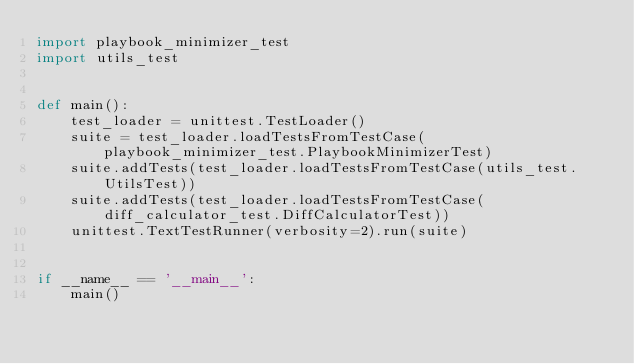<code> <loc_0><loc_0><loc_500><loc_500><_Python_>import playbook_minimizer_test
import utils_test


def main():
    test_loader = unittest.TestLoader()
    suite = test_loader.loadTestsFromTestCase(playbook_minimizer_test.PlaybookMinimizerTest)
    suite.addTests(test_loader.loadTestsFromTestCase(utils_test.UtilsTest))
    suite.addTests(test_loader.loadTestsFromTestCase(diff_calculator_test.DiffCalculatorTest))
    unittest.TextTestRunner(verbosity=2).run(suite)


if __name__ == '__main__':
    main()
</code> 